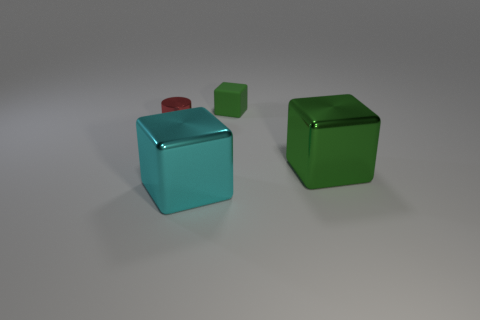Are there any other things that have the same color as the small cylinder?
Make the answer very short. No. What material is the big object that is on the right side of the metal object in front of the green metal thing?
Ensure brevity in your answer.  Metal. Is there another metallic object of the same shape as the big green metallic thing?
Keep it short and to the point. Yes. How many other objects are there of the same shape as the tiny red thing?
Offer a terse response. 0. The thing that is right of the cyan metallic cube and in front of the green rubber object has what shape?
Provide a succinct answer. Cube. What is the size of the green block that is on the left side of the large green block?
Provide a short and direct response. Small. Do the red metallic object and the cyan cube have the same size?
Provide a succinct answer. No. Are there fewer big metal objects on the left side of the tiny green rubber object than tiny shiny things that are to the right of the green metal thing?
Give a very brief answer. No. There is a block that is both behind the cyan shiny object and in front of the green rubber cube; what is its size?
Give a very brief answer. Large. There is a green block behind the tiny thing on the left side of the tiny matte thing; are there any green cubes left of it?
Offer a very short reply. No. 